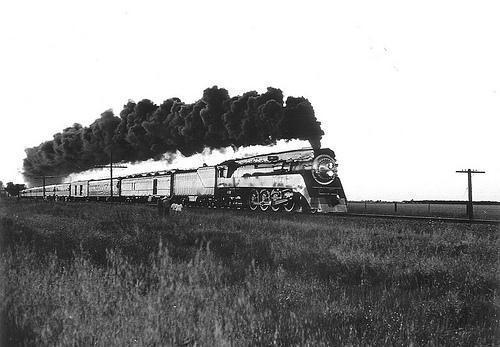How many trains are in the picture?
Give a very brief answer. 1. 